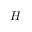Convert formula to latex. <formula><loc_0><loc_0><loc_500><loc_500>H</formula> 